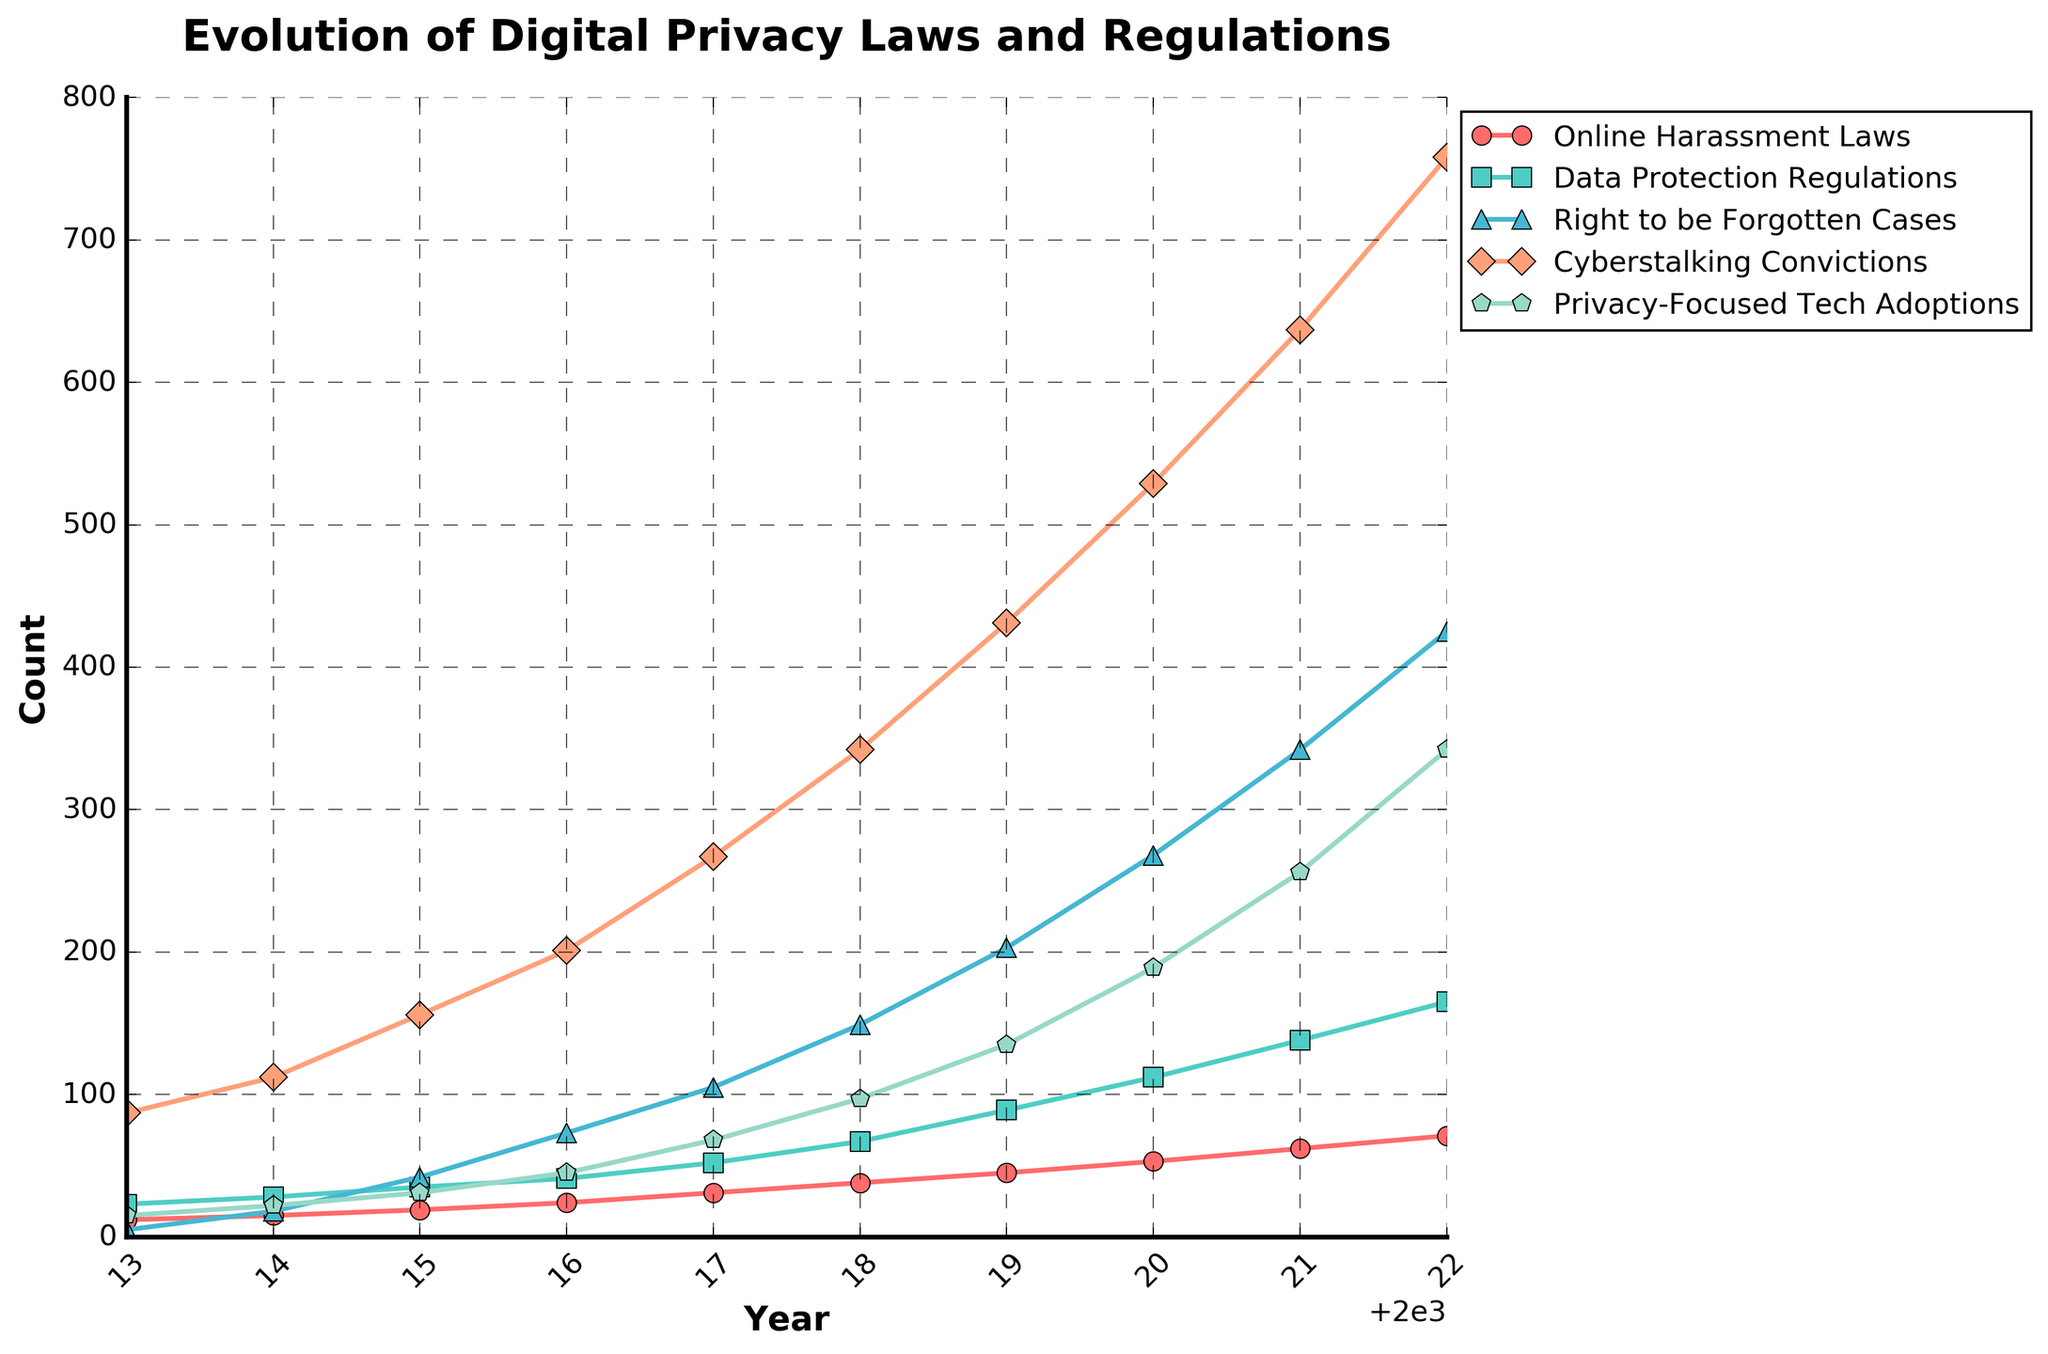What's the range of "Cyberstalking Convictions" from 2013 to 2022? The range is calculated by finding the difference between the maximum and minimum values of "Cyberstalking Convictions" over the given years. The maximum value is 758 (in 2022) and the minimum value is 87 (in 2013). Hence, the range is 758 - 87.
Answer: 671 Which category saw the highest increase in count from 2013 to 2022? To determine this, we subtract the 2013 value from the 2022 value for each category and compare the differences. "Cyberstalking Convictions" increased by (758 - 87 = 671), which is more than the increase in any other category.
Answer: Cyberstalking Convictions In what year did "Right to be Forgotten Cases" first exceed 100? By scanning the "Right to be Forgotten Cases" data across the years, we see that the count first exceeds 100 in 2017.
Answer: 2017 Which category had the lowest count in 2013? By referring to the data for 2013, "Right to be Forgotten Cases" had a count of 5, which is the lowest compared to other categories.
Answer: Right to be Forgotten Cases Comparatively, how did "Data Protection Regulations" and "Privacy-Focused Tech Adoptions" change from 2014 to 2018? We calculate the change for each category: "Data Protection Regulations" went from 28 in 2014 to 67 in 2018, an increase of 39 (67 - 28 = 39). "Privacy-Focused Tech Adoptions" went from 22 in 2014 to 97 in 2018, an increase of 75 (97 - 22 = 75). "Privacy-Focused Tech Adoptions" had a greater change.
Answer: Privacy-Focused Tech Adoptions showed a greater change How many years did "Online Harassment Laws" increases consistently without any drop? We check for "Online Harassment Laws" values year by year and see that the values are consistently increasing without any drop from 2013 to 2022.
Answer: 10 years By how much did "Data Protection Regulations" grow from 2013 to 2020? The growth is calculated by taking the difference between the 2020 and 2013 values: 112 (2020) - 23 (2013).
Answer: 89 What year had the highest rate of increase for "Privacy-Focused Tech Adoptions"? By calculating the yearly increase for "Privacy-Focused Tech Adoptions", we identify that the highest increase occurred from 2020 to 2021, increasing by (256 - 189 = 67).
Answer: 2021 What trend can you observe about "Right to be Forgotten Cases" from 2013 to 2022? Observing the trend, "Right to be Forgotten Cases" consistently increase each year from 5 in 2013 to 425 in 2022.
Answer: Increasing trend Between 2016 and 2017, which category experienced the highest percentage growth, and what was it? We calculate the percentage growth for all categories: "Online Harassment Laws" (31-24)/24 = 29.17%, "Data Protection Regulations" (52-41)/41 = 26.83%, "Right to be Forgotten Cases" (105-73)/73 = 43.84%, "Cyberstalking Convictions" (267-201)/201 = 32.84%, "Privacy-Focused Tech Adoptions" (68-45)/45 = 51.11%. "Privacy-Focused Tech Adoptions" experienced the highest percentage growth.
Answer: Privacy-Focused Tech Adoptions, 51.11% 